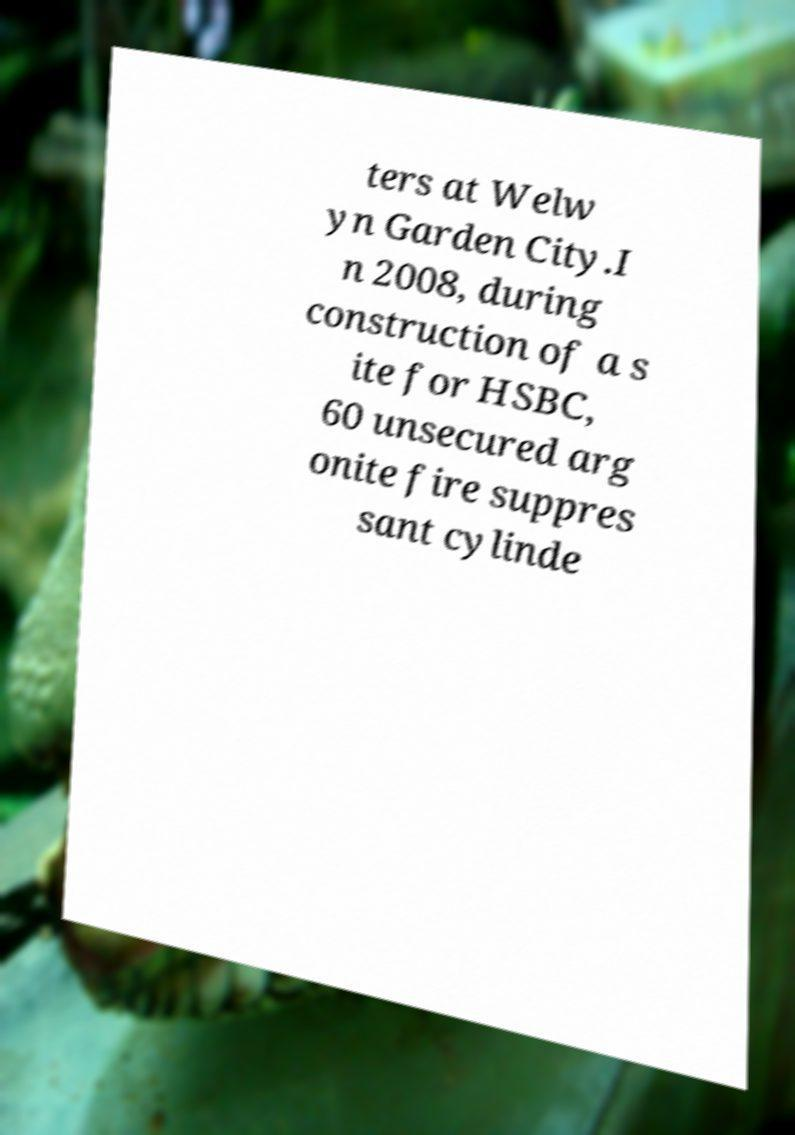What messages or text are displayed in this image? I need them in a readable, typed format. ters at Welw yn Garden City.I n 2008, during construction of a s ite for HSBC, 60 unsecured arg onite fire suppres sant cylinde 